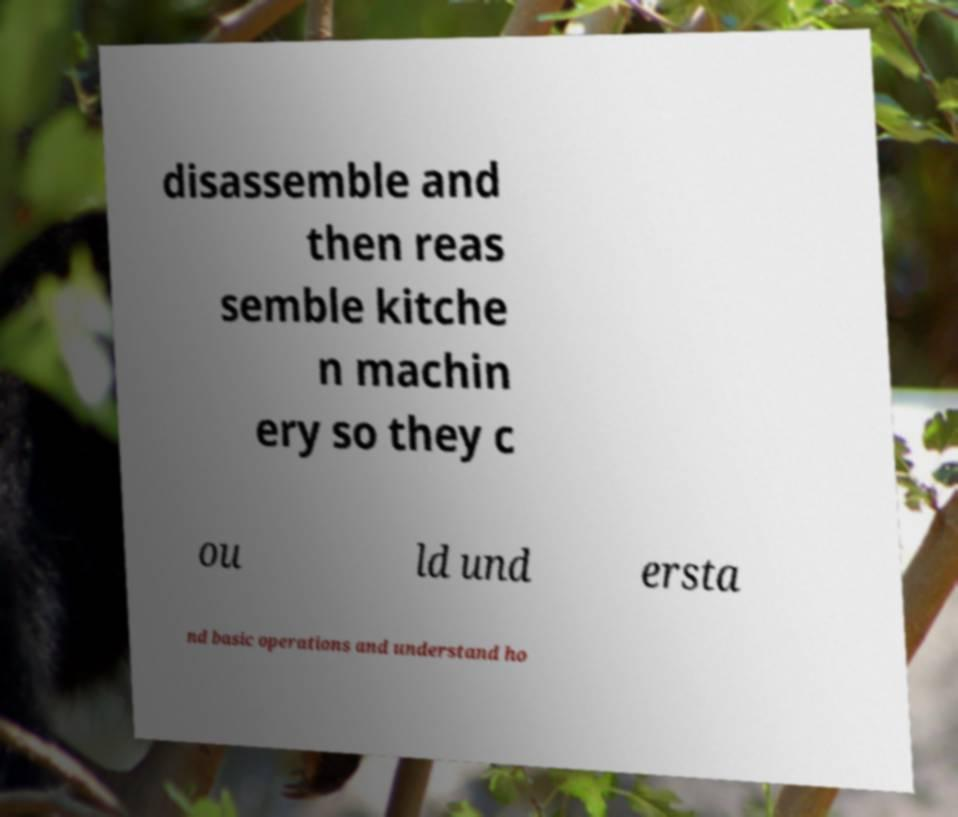What messages or text are displayed in this image? I need them in a readable, typed format. disassemble and then reas semble kitche n machin ery so they c ou ld und ersta nd basic operations and understand ho 